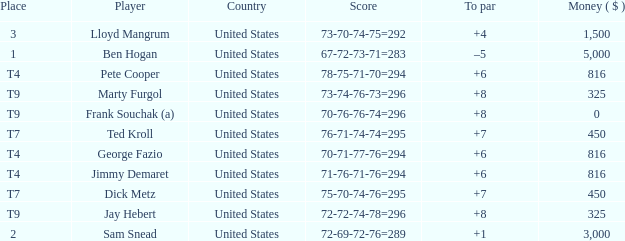What was Marty Furgol's place when he was paid less than $3,000? T9. 